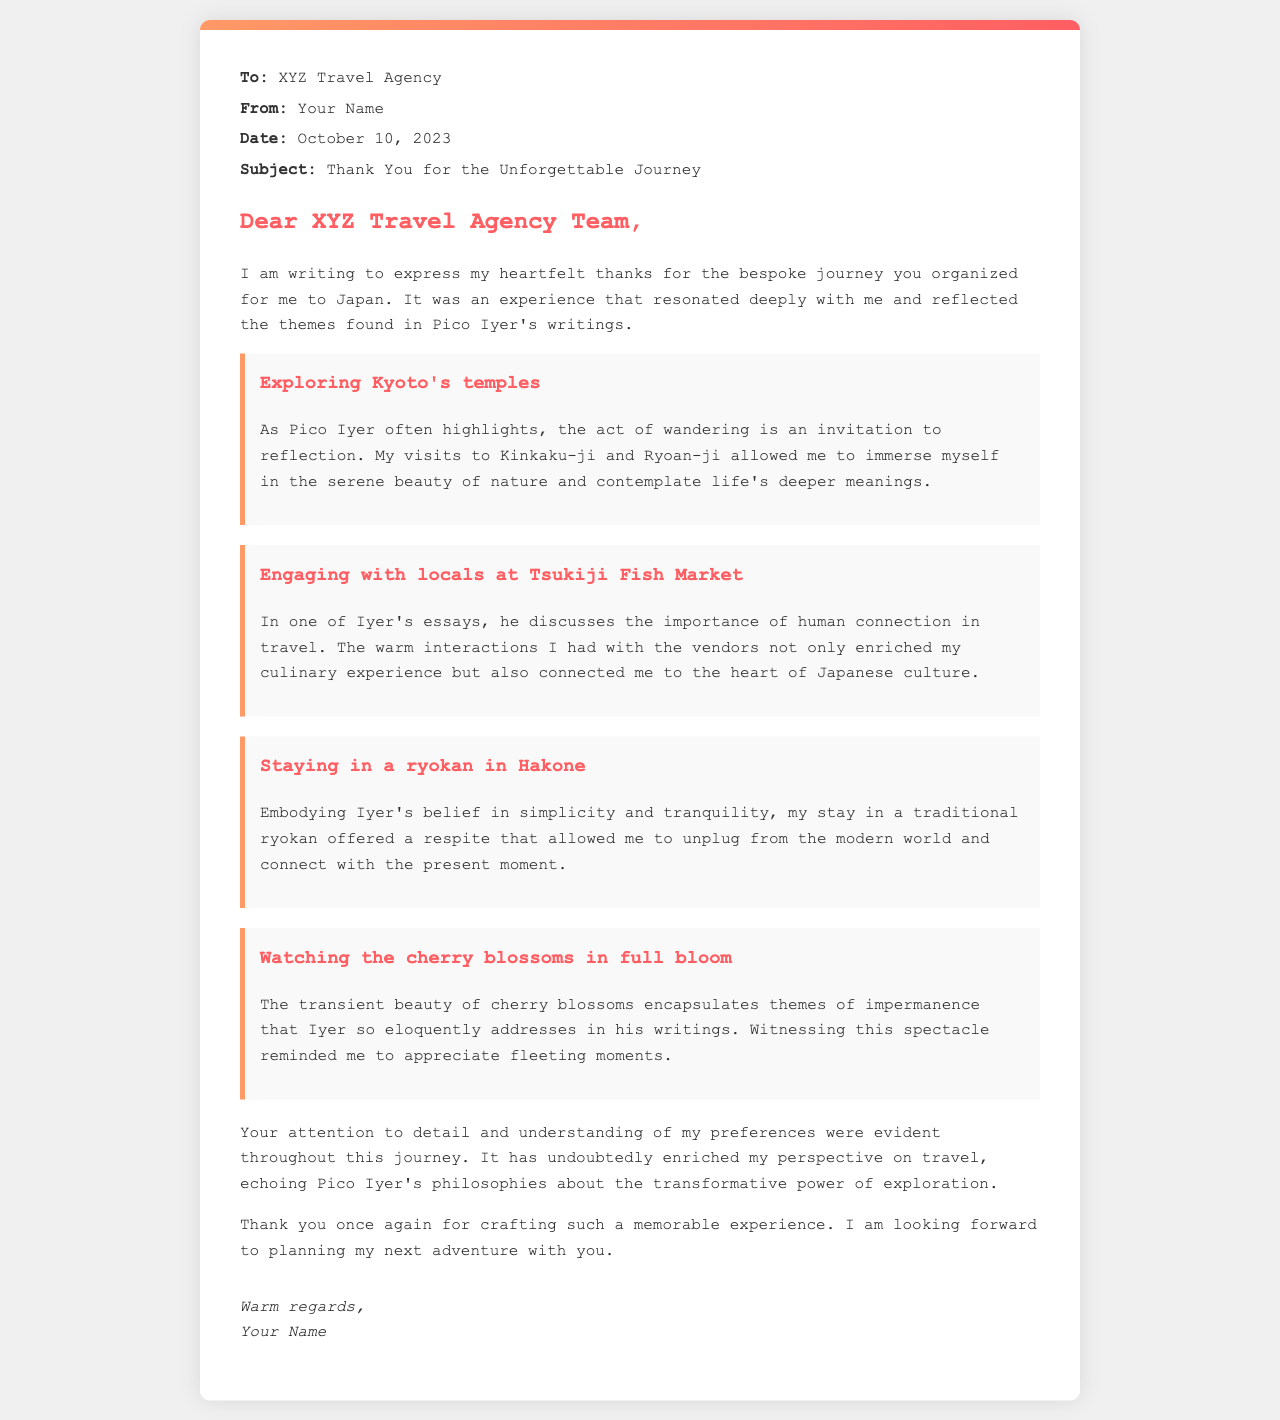What is the name of the travel agency? The travel agency that organized the journey is mentioned at the beginning of the letter.
Answer: XYZ Travel Agency What country did the journey take place in? The letter specifies that the journey organized was to Japan.
Answer: Japan What date was the letter written? The date is provided in the header of the letter.
Answer: October 10, 2023 Which temple in Kyoto is mentioned in the letter? The specific temples visited in Kyoto are listed in the experiences section.
Answer: Kinkaku-ji What theme does the experience at Tsukiji Fish Market highlight? The letter refers to a theme discussed by Pico Iyer regarding human interactions.
Answer: Human connection What type of accommodation was chosen in Hakone? The letter describes the type of lodging experienced during the journey.
Answer: Ryokan What natural spectacle is mentioned in the letter? The experience described in the letter captures a seasonal event in Japan.
Answer: Cherry blossoms Who is the author of the letter? The letter states a placeholder for the writer's name, which is indicated in the signature.
Answer: Your Name How does the author feel about the overall journey? The closing statement indicates the author's emotional response to the trip.
Answer: Enriched 